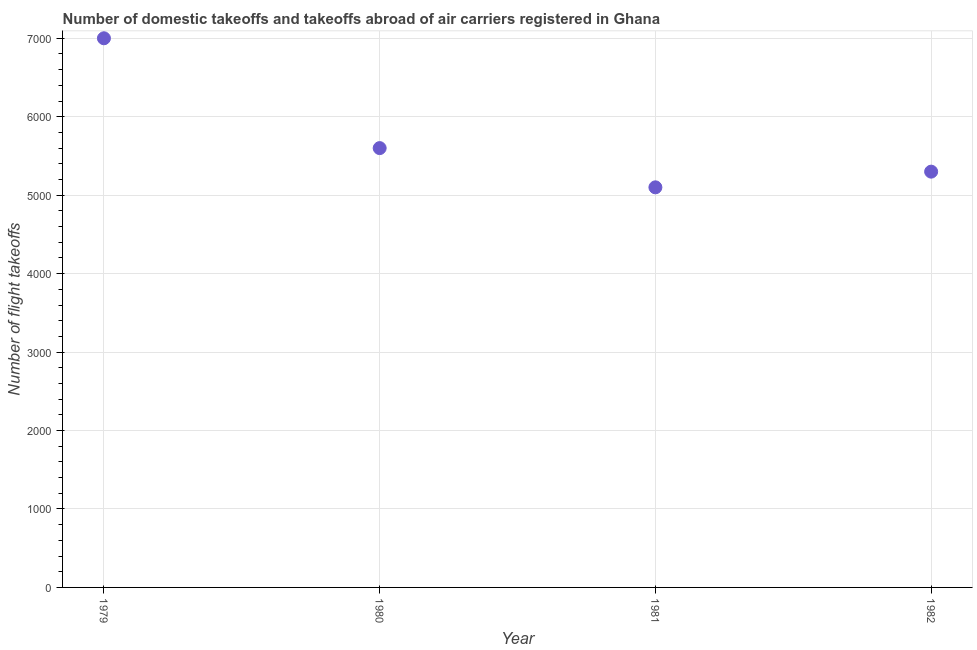What is the number of flight takeoffs in 1981?
Provide a succinct answer. 5100. Across all years, what is the maximum number of flight takeoffs?
Provide a short and direct response. 7000. Across all years, what is the minimum number of flight takeoffs?
Your answer should be very brief. 5100. In which year was the number of flight takeoffs maximum?
Ensure brevity in your answer.  1979. In which year was the number of flight takeoffs minimum?
Ensure brevity in your answer.  1981. What is the sum of the number of flight takeoffs?
Ensure brevity in your answer.  2.30e+04. What is the difference between the number of flight takeoffs in 1979 and 1980?
Ensure brevity in your answer.  1400. What is the average number of flight takeoffs per year?
Ensure brevity in your answer.  5750. What is the median number of flight takeoffs?
Your answer should be compact. 5450. In how many years, is the number of flight takeoffs greater than 1200 ?
Provide a short and direct response. 4. Do a majority of the years between 1982 and 1979 (inclusive) have number of flight takeoffs greater than 5400 ?
Give a very brief answer. Yes. What is the ratio of the number of flight takeoffs in 1979 to that in 1981?
Offer a very short reply. 1.37. Is the difference between the number of flight takeoffs in 1981 and 1982 greater than the difference between any two years?
Make the answer very short. No. What is the difference between the highest and the second highest number of flight takeoffs?
Ensure brevity in your answer.  1400. What is the difference between the highest and the lowest number of flight takeoffs?
Provide a short and direct response. 1900. How many years are there in the graph?
Give a very brief answer. 4. What is the title of the graph?
Ensure brevity in your answer.  Number of domestic takeoffs and takeoffs abroad of air carriers registered in Ghana. What is the label or title of the Y-axis?
Make the answer very short. Number of flight takeoffs. What is the Number of flight takeoffs in 1979?
Provide a short and direct response. 7000. What is the Number of flight takeoffs in 1980?
Provide a short and direct response. 5600. What is the Number of flight takeoffs in 1981?
Keep it short and to the point. 5100. What is the Number of flight takeoffs in 1982?
Offer a terse response. 5300. What is the difference between the Number of flight takeoffs in 1979 and 1980?
Offer a very short reply. 1400. What is the difference between the Number of flight takeoffs in 1979 and 1981?
Offer a terse response. 1900. What is the difference between the Number of flight takeoffs in 1979 and 1982?
Offer a very short reply. 1700. What is the difference between the Number of flight takeoffs in 1980 and 1981?
Your answer should be very brief. 500. What is the difference between the Number of flight takeoffs in 1980 and 1982?
Your answer should be compact. 300. What is the difference between the Number of flight takeoffs in 1981 and 1982?
Provide a short and direct response. -200. What is the ratio of the Number of flight takeoffs in 1979 to that in 1980?
Your response must be concise. 1.25. What is the ratio of the Number of flight takeoffs in 1979 to that in 1981?
Your response must be concise. 1.37. What is the ratio of the Number of flight takeoffs in 1979 to that in 1982?
Your answer should be very brief. 1.32. What is the ratio of the Number of flight takeoffs in 1980 to that in 1981?
Make the answer very short. 1.1. What is the ratio of the Number of flight takeoffs in 1980 to that in 1982?
Offer a very short reply. 1.06. 